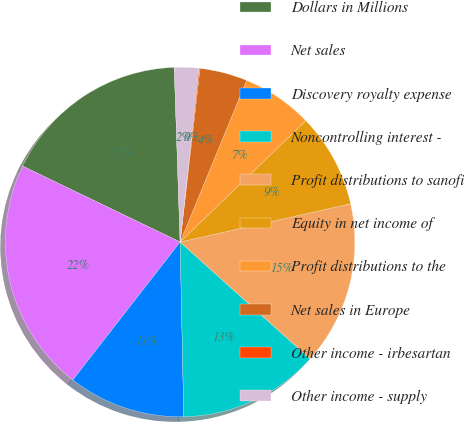<chart> <loc_0><loc_0><loc_500><loc_500><pie_chart><fcel>Dollars in Millions<fcel>Net sales<fcel>Discovery royalty expense<fcel>Noncontrolling interest -<fcel>Profit distributions to sanofi<fcel>Equity in net income of<fcel>Profit distributions to the<fcel>Net sales in Europe<fcel>Other income - irbesartan<fcel>Other income - supply<nl><fcel>17.32%<fcel>21.62%<fcel>10.86%<fcel>13.01%<fcel>15.17%<fcel>8.71%<fcel>6.56%<fcel>4.4%<fcel>0.1%<fcel>2.25%<nl></chart> 